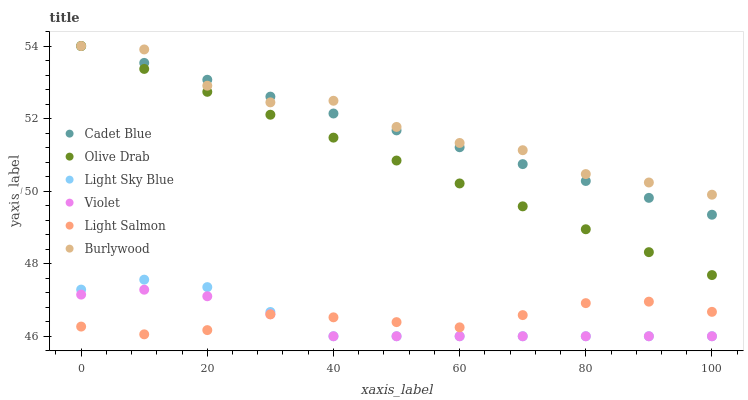Does Violet have the minimum area under the curve?
Answer yes or no. Yes. Does Burlywood have the maximum area under the curve?
Answer yes or no. Yes. Does Cadet Blue have the minimum area under the curve?
Answer yes or no. No. Does Cadet Blue have the maximum area under the curve?
Answer yes or no. No. Is Olive Drab the smoothest?
Answer yes or no. Yes. Is Burlywood the roughest?
Answer yes or no. Yes. Is Cadet Blue the smoothest?
Answer yes or no. No. Is Cadet Blue the roughest?
Answer yes or no. No. Does Light Sky Blue have the lowest value?
Answer yes or no. Yes. Does Cadet Blue have the lowest value?
Answer yes or no. No. Does Olive Drab have the highest value?
Answer yes or no. Yes. Does Light Sky Blue have the highest value?
Answer yes or no. No. Is Light Salmon less than Cadet Blue?
Answer yes or no. Yes. Is Cadet Blue greater than Light Salmon?
Answer yes or no. Yes. Does Burlywood intersect Cadet Blue?
Answer yes or no. Yes. Is Burlywood less than Cadet Blue?
Answer yes or no. No. Is Burlywood greater than Cadet Blue?
Answer yes or no. No. Does Light Salmon intersect Cadet Blue?
Answer yes or no. No. 